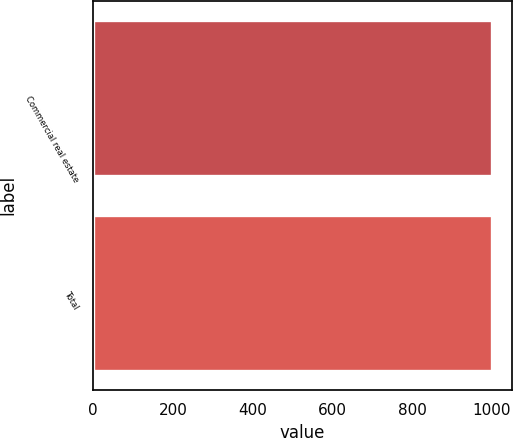<chart> <loc_0><loc_0><loc_500><loc_500><bar_chart><fcel>Commercial real estate<fcel>Total<nl><fcel>1000<fcel>1000.1<nl></chart> 